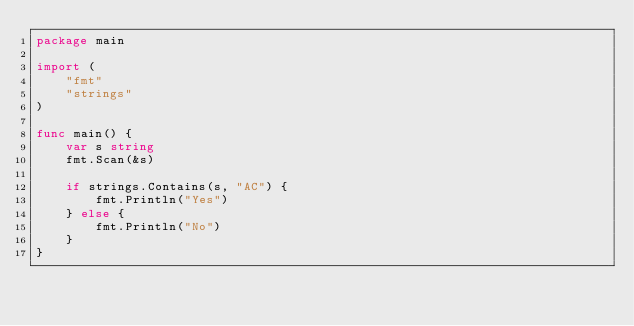<code> <loc_0><loc_0><loc_500><loc_500><_Go_>package main

import (
	"fmt"
	"strings"
)

func main() {
	var s string
	fmt.Scan(&s)

	if strings.Contains(s, "AC") {
		fmt.Println("Yes")
	} else {
		fmt.Println("No")
	}
}
</code> 